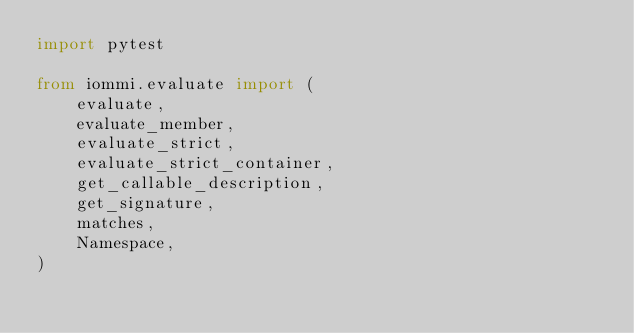<code> <loc_0><loc_0><loc_500><loc_500><_Python_>import pytest

from iommi.evaluate import (
    evaluate,
    evaluate_member,
    evaluate_strict,
    evaluate_strict_container,
    get_callable_description,
    get_signature,
    matches,
    Namespace,
)

</code> 